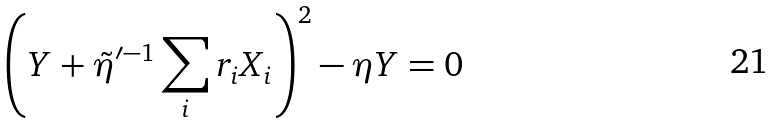<formula> <loc_0><loc_0><loc_500><loc_500>\left ( Y + \tilde { \eta } ^ { \prime - 1 } \sum _ { i } r _ { i } X _ { i } \right ) ^ { 2 } - \eta Y = 0</formula> 